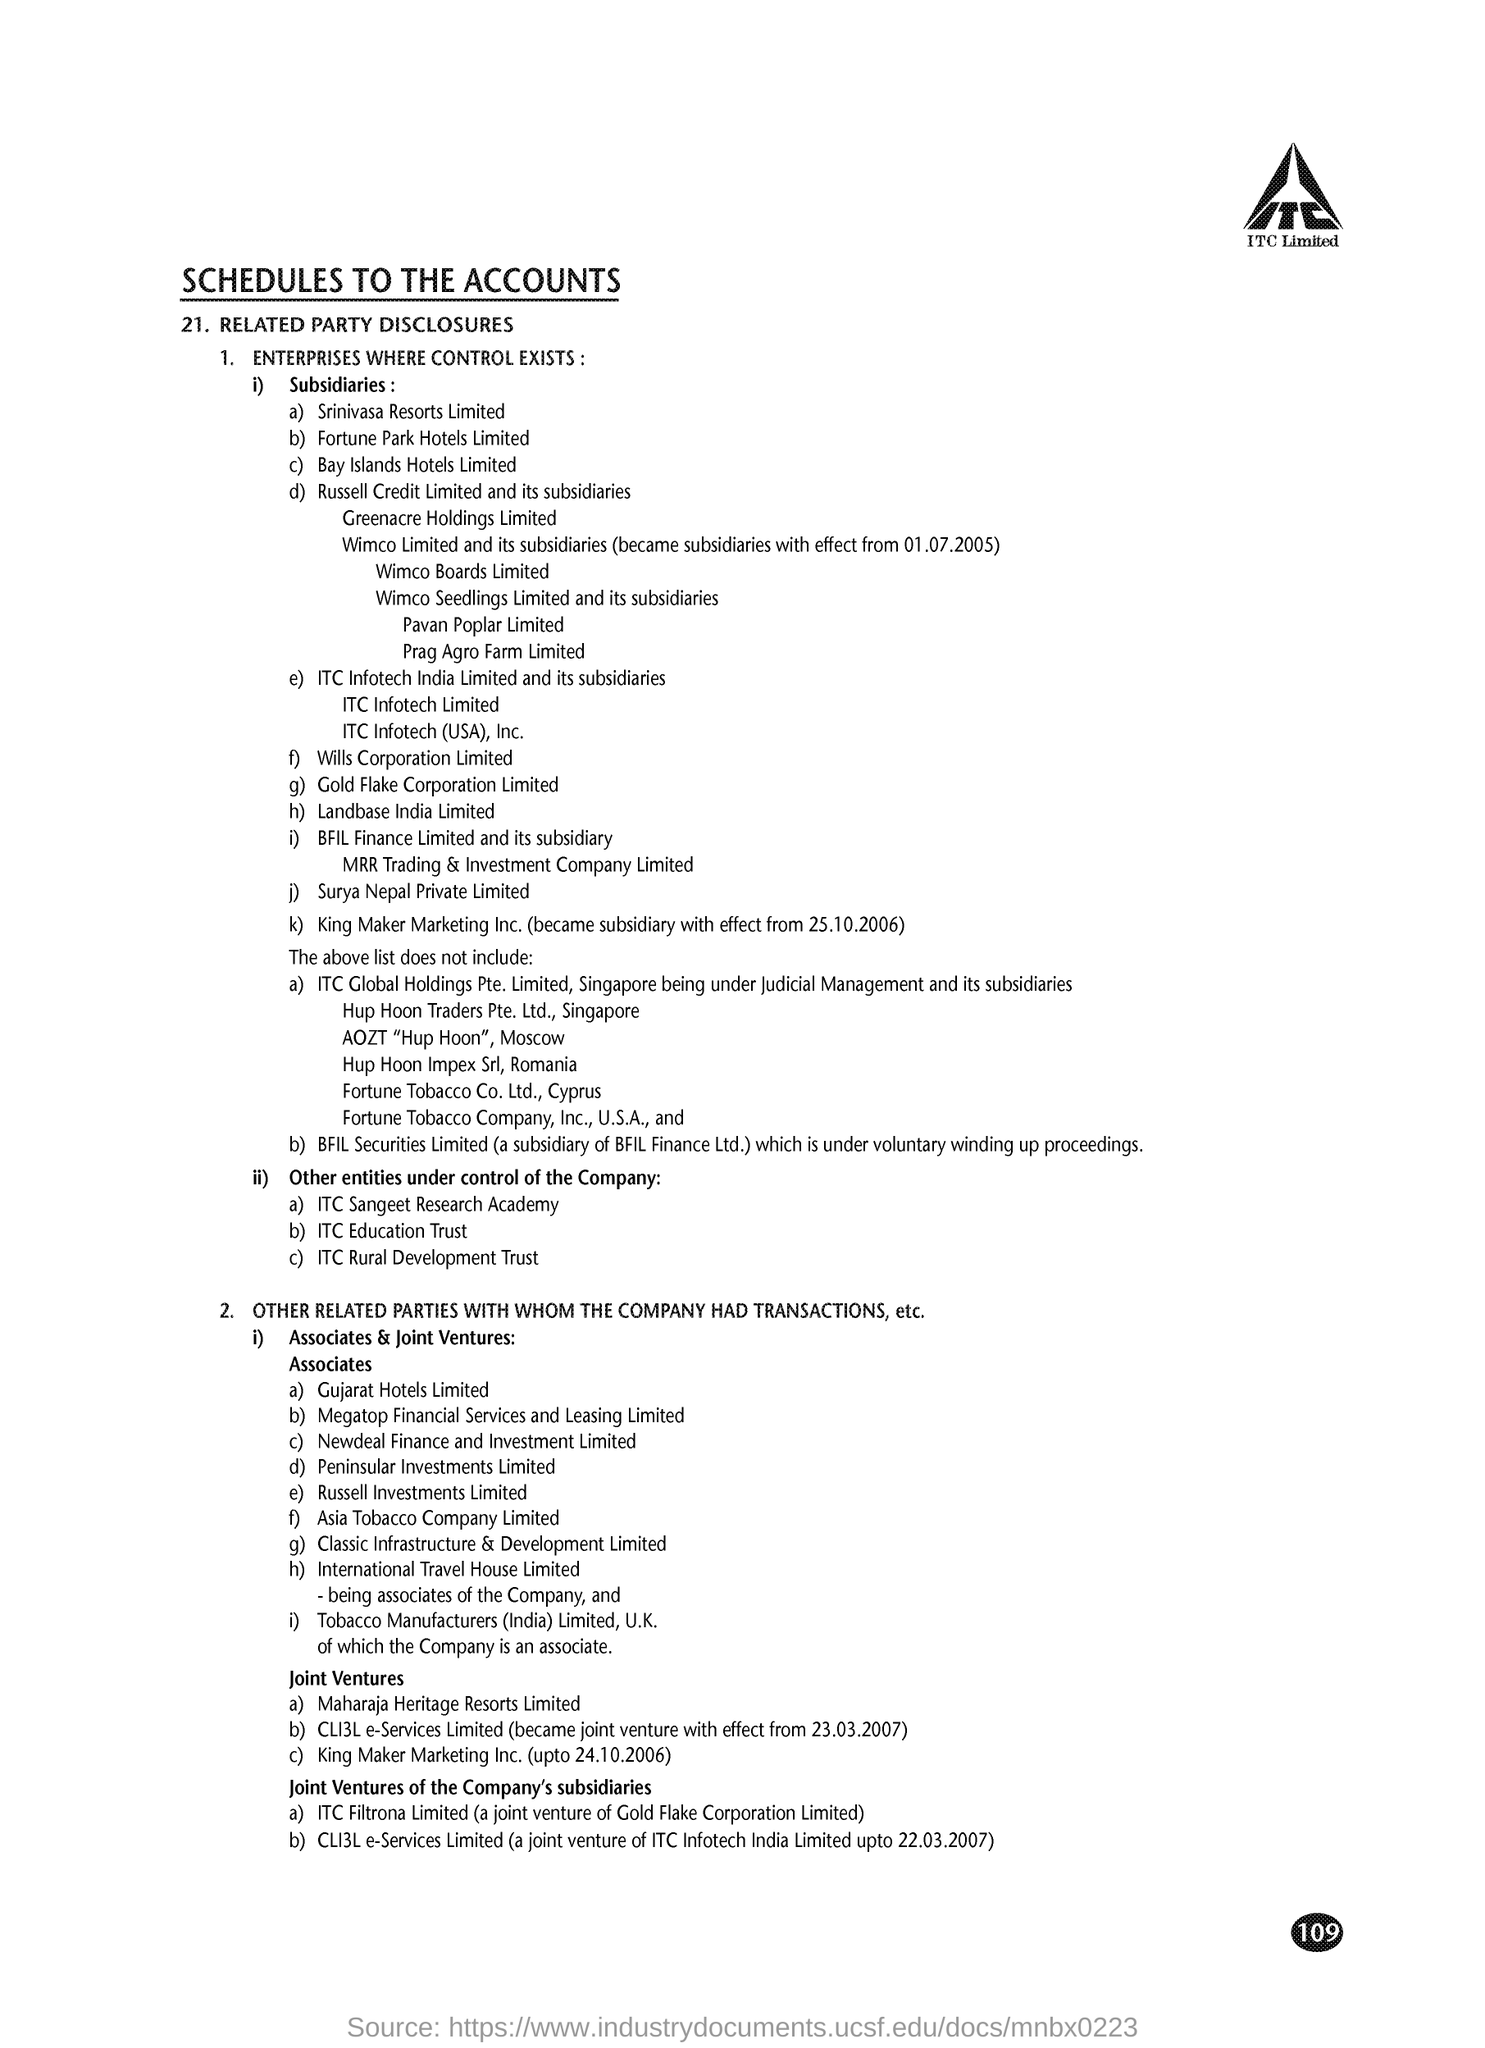Mention a couple of crucial points in this snapshot. Point number 21 in the document is "Related Party Disclosures. ITC Limited is the company whose name appears at the top of the page. What is the title of the document? Schedules to the Accounts. 